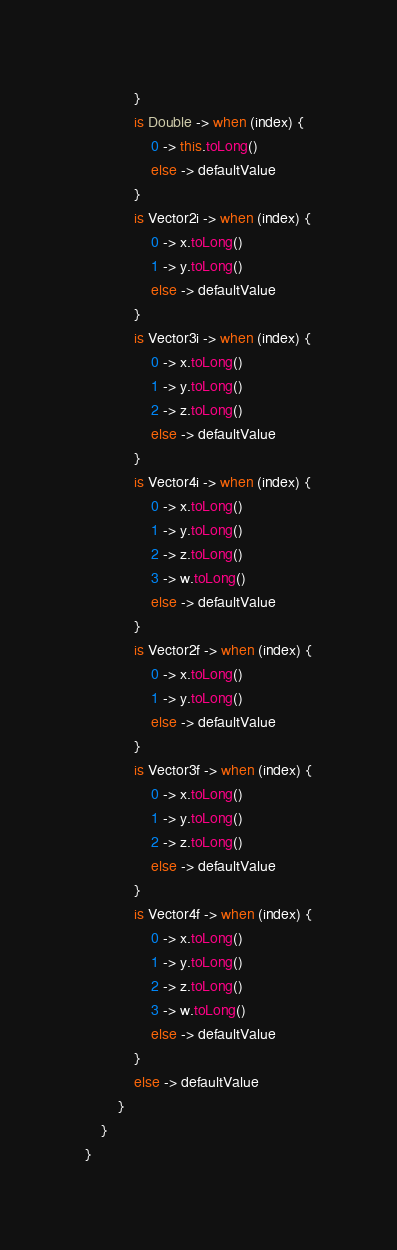Convert code to text. <code><loc_0><loc_0><loc_500><loc_500><_Kotlin_>            }
            is Double -> when (index) {
                0 -> this.toLong()
                else -> defaultValue
            }
            is Vector2i -> when (index) {
                0 -> x.toLong()
                1 -> y.toLong()
                else -> defaultValue
            }
            is Vector3i -> when (index) {
                0 -> x.toLong()
                1 -> y.toLong()
                2 -> z.toLong()
                else -> defaultValue
            }
            is Vector4i -> when (index) {
                0 -> x.toLong()
                1 -> y.toLong()
                2 -> z.toLong()
                3 -> w.toLong()
                else -> defaultValue
            }
            is Vector2f -> when (index) {
                0 -> x.toLong()
                1 -> y.toLong()
                else -> defaultValue
            }
            is Vector3f -> when (index) {
                0 -> x.toLong()
                1 -> y.toLong()
                2 -> z.toLong()
                else -> defaultValue
            }
            is Vector4f -> when (index) {
                0 -> x.toLong()
                1 -> y.toLong()
                2 -> z.toLong()
                3 -> w.toLong()
                else -> defaultValue
            }
            else -> defaultValue
        }
    }
}</code> 